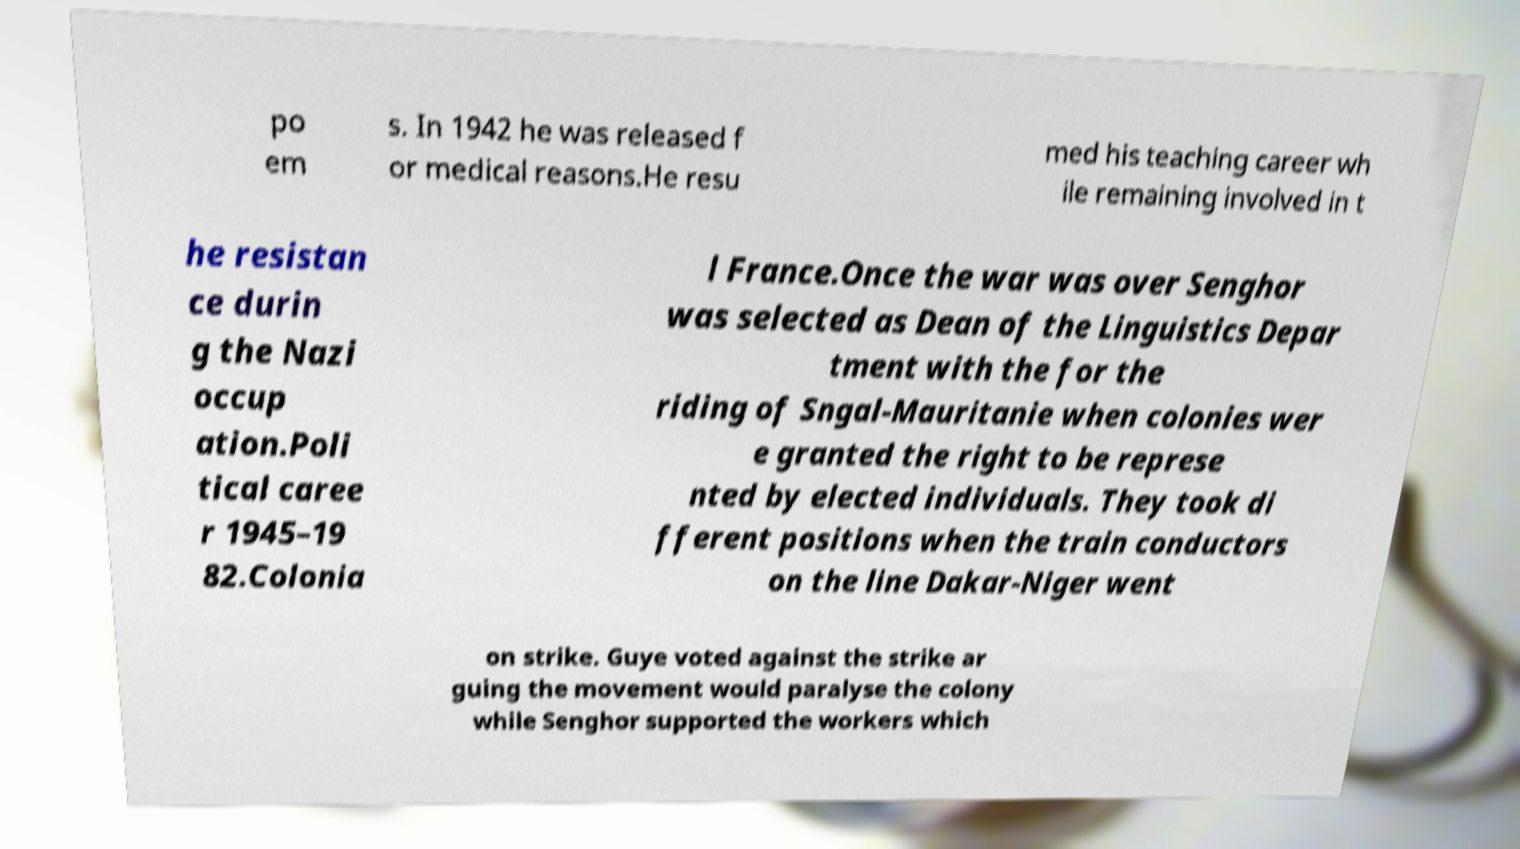Can you read and provide the text displayed in the image?This photo seems to have some interesting text. Can you extract and type it out for me? po em s. In 1942 he was released f or medical reasons.He resu med his teaching career wh ile remaining involved in t he resistan ce durin g the Nazi occup ation.Poli tical caree r 1945–19 82.Colonia l France.Once the war was over Senghor was selected as Dean of the Linguistics Depar tment with the for the riding of Sngal-Mauritanie when colonies wer e granted the right to be represe nted by elected individuals. They took di fferent positions when the train conductors on the line Dakar-Niger went on strike. Guye voted against the strike ar guing the movement would paralyse the colony while Senghor supported the workers which 